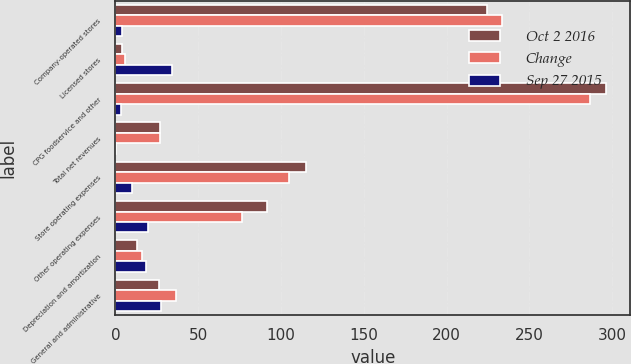Convert chart to OTSL. <chart><loc_0><loc_0><loc_500><loc_500><stacked_bar_chart><ecel><fcel>Company-operated stores<fcel>Licensed stores<fcel>CPG foodservice and other<fcel>Total net revenues<fcel>Store operating expenses<fcel>Other operating expenses<fcel>Depreciation and amortization<fcel>General and administrative<nl><fcel>Oct 2 2016<fcel>224.3<fcel>3.9<fcel>296.1<fcel>27.05<fcel>115<fcel>91.4<fcel>13.3<fcel>26.5<nl><fcel>Change<fcel>233.2<fcel>5.9<fcel>286.7<fcel>27.05<fcel>104.7<fcel>76.5<fcel>16.3<fcel>36.6<nl><fcel>Sep 27 2015<fcel>3.8<fcel>33.9<fcel>3.3<fcel>0.3<fcel>9.8<fcel>19.5<fcel>18.4<fcel>27.6<nl></chart> 